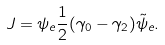<formula> <loc_0><loc_0><loc_500><loc_500>J = \psi _ { e } \frac { 1 } { 2 } ( \gamma _ { 0 } - \gamma _ { 2 } ) \tilde { \psi } _ { e } .</formula> 